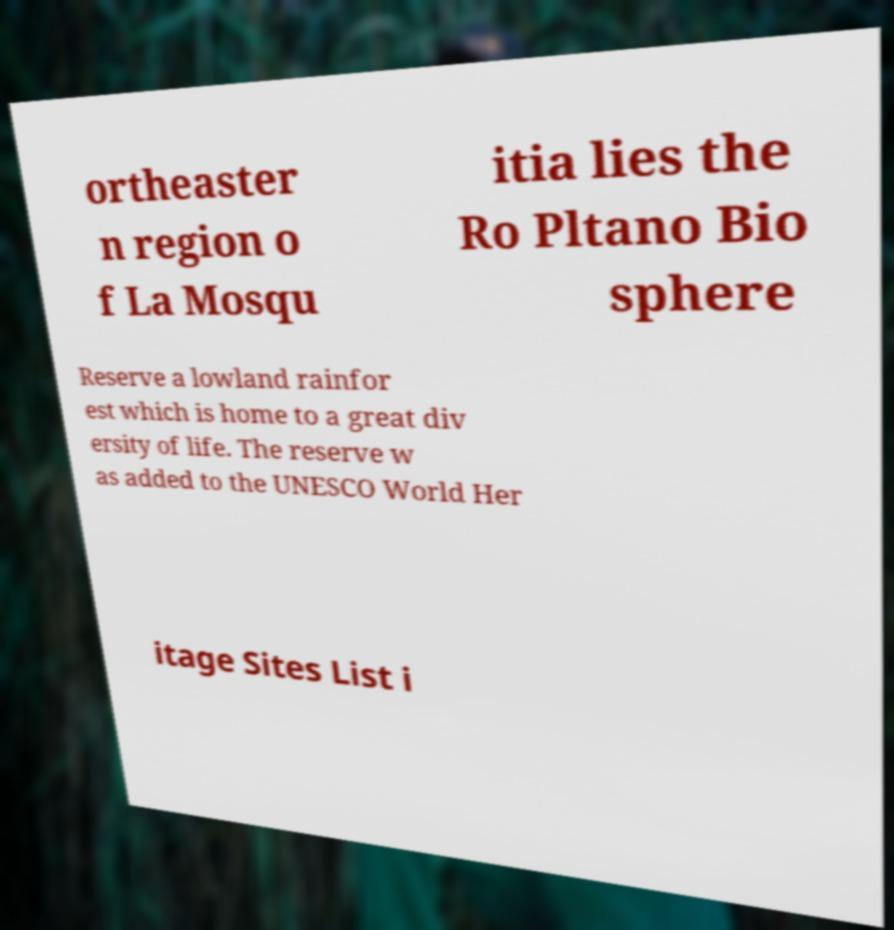Please read and relay the text visible in this image. What does it say? ortheaster n region o f La Mosqu itia lies the Ro Pltano Bio sphere Reserve a lowland rainfor est which is home to a great div ersity of life. The reserve w as added to the UNESCO World Her itage Sites List i 